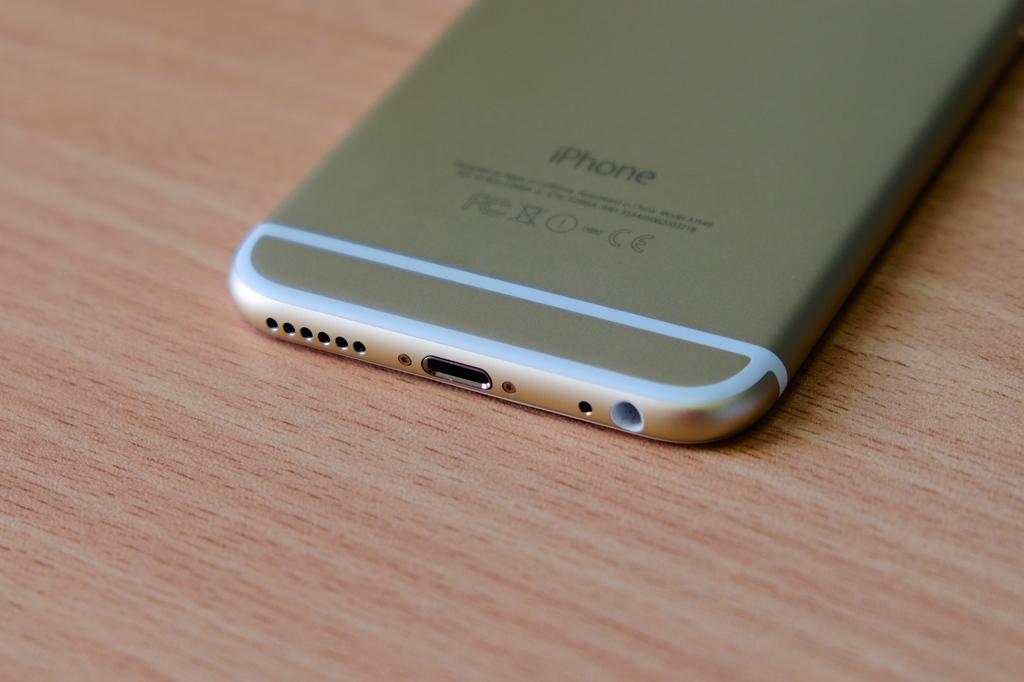What brand is this phone?
Provide a succinct answer. Iphone. What are the letters to the left of the symbols?
Offer a terse response. Fc. 